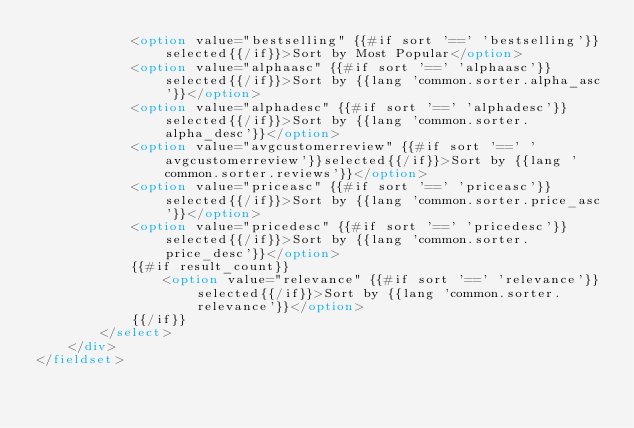Convert code to text. <code><loc_0><loc_0><loc_500><loc_500><_HTML_>            <option value="bestselling" {{#if sort '==' 'bestselling'}}selected{{/if}}>Sort by Most Popular</option>
            <option value="alphaasc" {{#if sort '==' 'alphaasc'}}selected{{/if}}>Sort by {{lang 'common.sorter.alpha_asc'}}</option>
            <option value="alphadesc" {{#if sort '==' 'alphadesc'}}selected{{/if}}>Sort by {{lang 'common.sorter.alpha_desc'}}</option>
            <option value="avgcustomerreview" {{#if sort '==' 'avgcustomerreview'}}selected{{/if}}>Sort by {{lang 'common.sorter.reviews'}}</option>
            <option value="priceasc" {{#if sort '==' 'priceasc'}}selected{{/if}}>Sort by {{lang 'common.sorter.price_asc'}}</option>
            <option value="pricedesc" {{#if sort '==' 'pricedesc'}}selected{{/if}}>Sort by {{lang 'common.sorter.price_desc'}}</option>
            {{#if result_count}}
                <option value="relevance" {{#if sort '==' 'relevance'}}selected{{/if}}>Sort by {{lang 'common.sorter.relevance'}}</option>
            {{/if}}
        </select>
    </div>
</fieldset>

</code> 